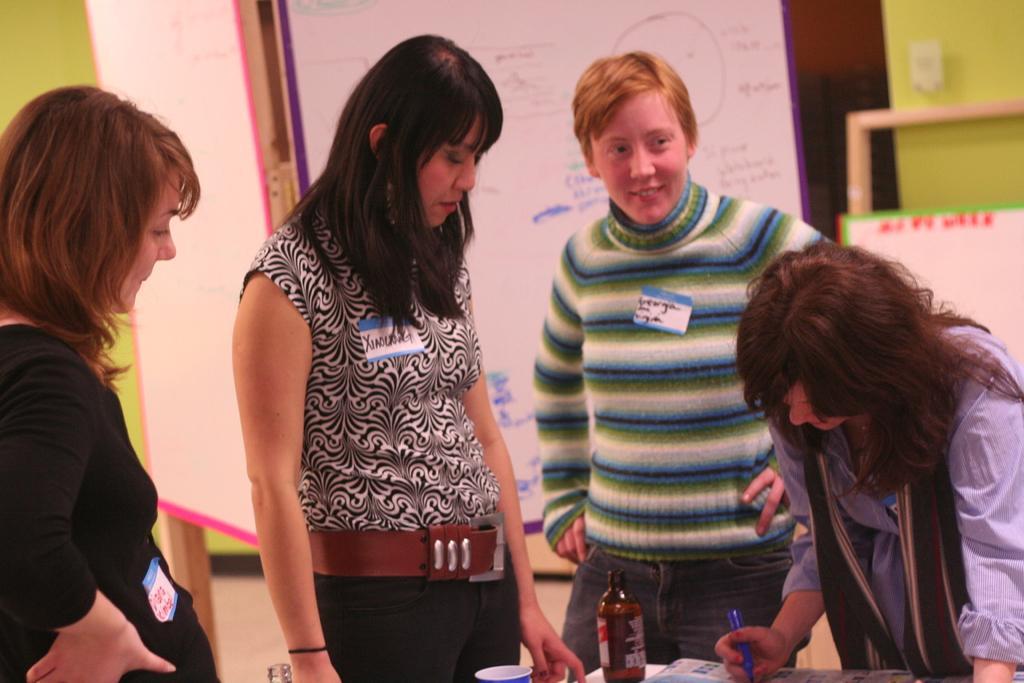Describe this image in one or two sentences. In this image I can see few women are standing and on the right side I can see one of them is holding a blue colour thing. I can also see a paper thing on their dresses and on it I can see something is written. In the front of them I can see a bottle, a glass and one more thing. In the background I can see few white colour boards and on it I can see something is written. 